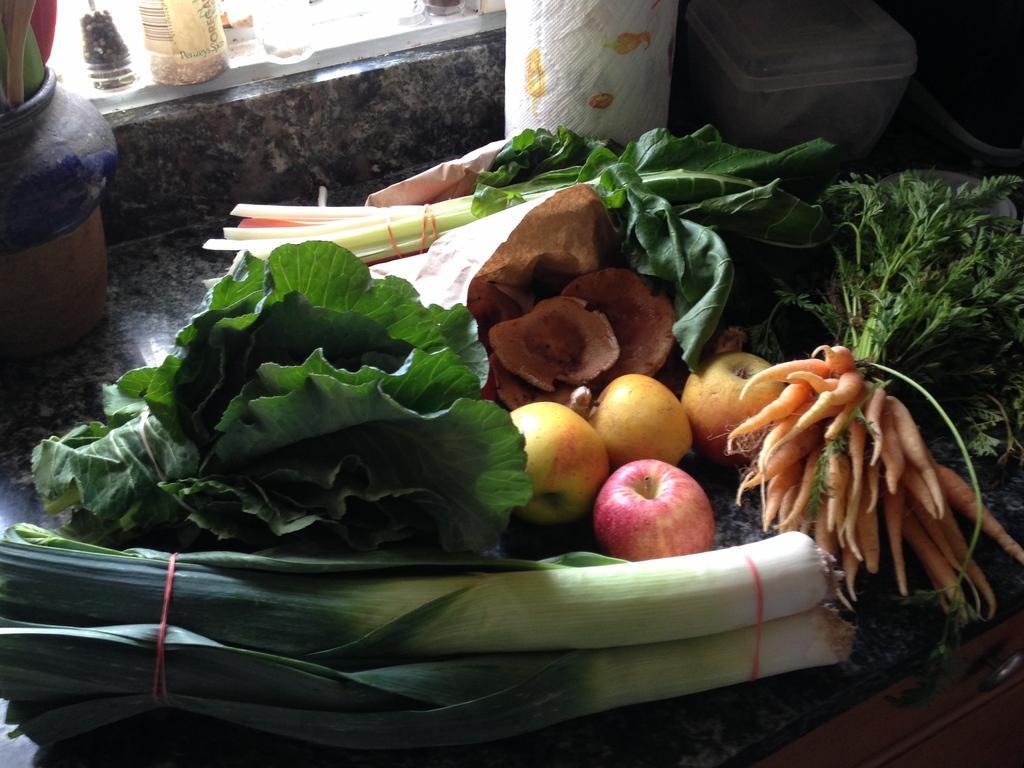Please provide a concise description of this image. In this image in the center there are some vegetables, carrots and some leafy vegetables. In the background there are some boxes, not, bottles. At the bottom there is cupboard. 